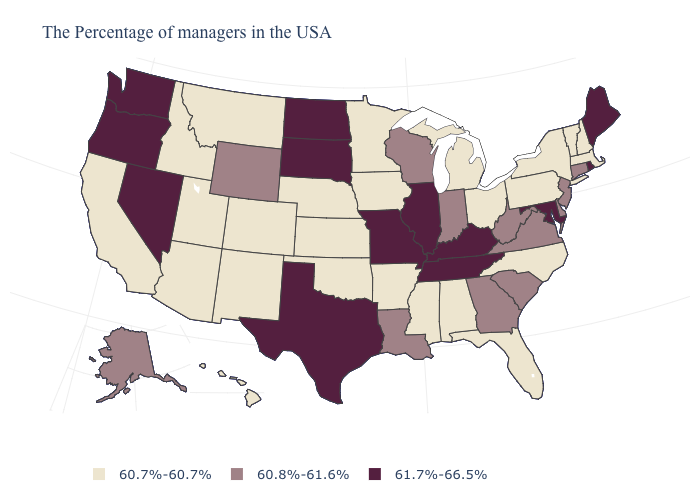Name the states that have a value in the range 61.7%-66.5%?
Answer briefly. Maine, Rhode Island, Maryland, Kentucky, Tennessee, Illinois, Missouri, Texas, South Dakota, North Dakota, Nevada, Washington, Oregon. Among the states that border New Hampshire , which have the lowest value?
Be succinct. Massachusetts, Vermont. What is the value of Missouri?
Short answer required. 61.7%-66.5%. Which states have the lowest value in the South?
Concise answer only. North Carolina, Florida, Alabama, Mississippi, Arkansas, Oklahoma. Name the states that have a value in the range 61.7%-66.5%?
Short answer required. Maine, Rhode Island, Maryland, Kentucky, Tennessee, Illinois, Missouri, Texas, South Dakota, North Dakota, Nevada, Washington, Oregon. What is the highest value in states that border Georgia?
Answer briefly. 61.7%-66.5%. What is the value of Colorado?
Give a very brief answer. 60.7%-60.7%. Does the first symbol in the legend represent the smallest category?
Be succinct. Yes. Name the states that have a value in the range 60.7%-60.7%?
Answer briefly. Massachusetts, New Hampshire, Vermont, New York, Pennsylvania, North Carolina, Ohio, Florida, Michigan, Alabama, Mississippi, Arkansas, Minnesota, Iowa, Kansas, Nebraska, Oklahoma, Colorado, New Mexico, Utah, Montana, Arizona, Idaho, California, Hawaii. What is the lowest value in the Northeast?
Keep it brief. 60.7%-60.7%. What is the lowest value in the South?
Concise answer only. 60.7%-60.7%. Which states have the lowest value in the USA?
Give a very brief answer. Massachusetts, New Hampshire, Vermont, New York, Pennsylvania, North Carolina, Ohio, Florida, Michigan, Alabama, Mississippi, Arkansas, Minnesota, Iowa, Kansas, Nebraska, Oklahoma, Colorado, New Mexico, Utah, Montana, Arizona, Idaho, California, Hawaii. What is the lowest value in states that border Oklahoma?
Concise answer only. 60.7%-60.7%. Name the states that have a value in the range 60.8%-61.6%?
Concise answer only. Connecticut, New Jersey, Delaware, Virginia, South Carolina, West Virginia, Georgia, Indiana, Wisconsin, Louisiana, Wyoming, Alaska. 